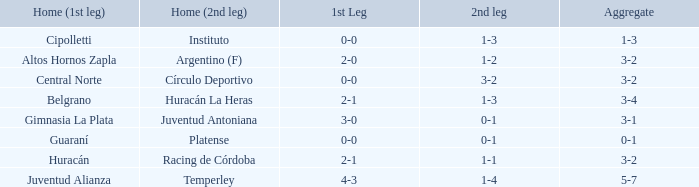What was the score of the 2nd leg when the Belgrano played the first leg at home with a score of 2-1? 1-3. 